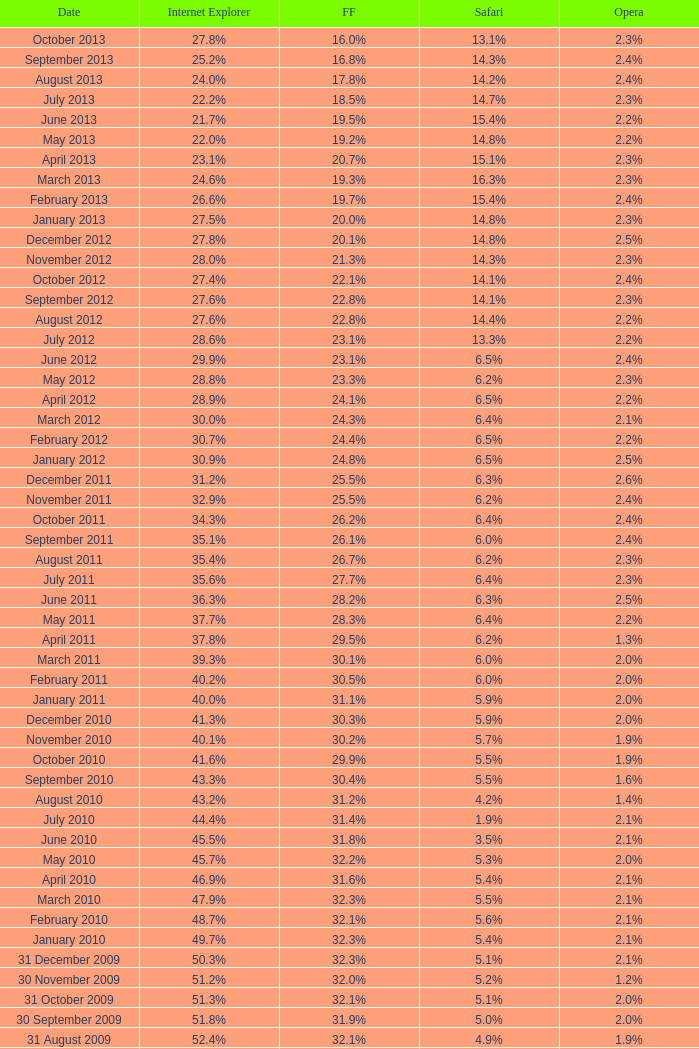What is the safari value with a 2.4% opera and 29.9% internet explorer? 6.5%. Would you be able to parse every entry in this table? {'header': ['Date', 'Internet Explorer', 'FF', 'Safari', 'Opera'], 'rows': [['October 2013', '27.8%', '16.0%', '13.1%', '2.3%'], ['September 2013', '25.2%', '16.8%', '14.3%', '2.4%'], ['August 2013', '24.0%', '17.8%', '14.2%', '2.4%'], ['July 2013', '22.2%', '18.5%', '14.7%', '2.3%'], ['June 2013', '21.7%', '19.5%', '15.4%', '2.2%'], ['May 2013', '22.0%', '19.2%', '14.8%', '2.2%'], ['April 2013', '23.1%', '20.7%', '15.1%', '2.3%'], ['March 2013', '24.6%', '19.3%', '16.3%', '2.3%'], ['February 2013', '26.6%', '19.7%', '15.4%', '2.4%'], ['January 2013', '27.5%', '20.0%', '14.8%', '2.3%'], ['December 2012', '27.8%', '20.1%', '14.8%', '2.5%'], ['November 2012', '28.0%', '21.3%', '14.3%', '2.3%'], ['October 2012', '27.4%', '22.1%', '14.1%', '2.4%'], ['September 2012', '27.6%', '22.8%', '14.1%', '2.3%'], ['August 2012', '27.6%', '22.8%', '14.4%', '2.2%'], ['July 2012', '28.6%', '23.1%', '13.3%', '2.2%'], ['June 2012', '29.9%', '23.1%', '6.5%', '2.4%'], ['May 2012', '28.8%', '23.3%', '6.2%', '2.3%'], ['April 2012', '28.9%', '24.1%', '6.5%', '2.2%'], ['March 2012', '30.0%', '24.3%', '6.4%', '2.1%'], ['February 2012', '30.7%', '24.4%', '6.5%', '2.2%'], ['January 2012', '30.9%', '24.8%', '6.5%', '2.5%'], ['December 2011', '31.2%', '25.5%', '6.3%', '2.6%'], ['November 2011', '32.9%', '25.5%', '6.2%', '2.4%'], ['October 2011', '34.3%', '26.2%', '6.4%', '2.4%'], ['September 2011', '35.1%', '26.1%', '6.0%', '2.4%'], ['August 2011', '35.4%', '26.7%', '6.2%', '2.3%'], ['July 2011', '35.6%', '27.7%', '6.4%', '2.3%'], ['June 2011', '36.3%', '28.2%', '6.3%', '2.5%'], ['May 2011', '37.7%', '28.3%', '6.4%', '2.2%'], ['April 2011', '37.8%', '29.5%', '6.2%', '1.3%'], ['March 2011', '39.3%', '30.1%', '6.0%', '2.0%'], ['February 2011', '40.2%', '30.5%', '6.0%', '2.0%'], ['January 2011', '40.0%', '31.1%', '5.9%', '2.0%'], ['December 2010', '41.3%', '30.3%', '5.9%', '2.0%'], ['November 2010', '40.1%', '30.2%', '5.7%', '1.9%'], ['October 2010', '41.6%', '29.9%', '5.5%', '1.9%'], ['September 2010', '43.3%', '30.4%', '5.5%', '1.6%'], ['August 2010', '43.2%', '31.2%', '4.2%', '1.4%'], ['July 2010', '44.4%', '31.4%', '1.9%', '2.1%'], ['June 2010', '45.5%', '31.8%', '3.5%', '2.1%'], ['May 2010', '45.7%', '32.2%', '5.3%', '2.0%'], ['April 2010', '46.9%', '31.6%', '5.4%', '2.1%'], ['March 2010', '47.9%', '32.3%', '5.5%', '2.1%'], ['February 2010', '48.7%', '32.1%', '5.6%', '2.1%'], ['January 2010', '49.7%', '32.3%', '5.4%', '2.1%'], ['31 December 2009', '50.3%', '32.3%', '5.1%', '2.1%'], ['30 November 2009', '51.2%', '32.0%', '5.2%', '1.2%'], ['31 October 2009', '51.3%', '32.1%', '5.1%', '2.0%'], ['30 September 2009', '51.8%', '31.9%', '5.0%', '2.0%'], ['31 August 2009', '52.4%', '32.1%', '4.9%', '1.9%'], ['31 July 2009', '53.1%', '31.7%', '4.6%', '1.8%'], ['30 June 2009', '57.1%', '31.6%', '3.2%', '2.0%'], ['31 May 2009', '57.5%', '31.4%', '3.1%', '2.0%'], ['30 April 2009', '57.6%', '31.6%', '2.9%', '2.0%'], ['31 March 2009', '57.8%', '31.5%', '2.8%', '2.0%'], ['28 February 2009', '58.1%', '31.3%', '2.7%', '2.0%'], ['31 January 2009', '58.4%', '31.1%', '2.7%', '2.0%'], ['31 December 2008', '58.6%', '31.1%', '2.9%', '2.1%'], ['30 November 2008', '59.0%', '30.8%', '3.0%', '2.0%'], ['31 October 2008', '59.4%', '30.6%', '3.0%', '2.0%'], ['30 September 2008', '57.3%', '32.5%', '2.7%', '2.0%'], ['31 August 2008', '58.7%', '31.4%', '2.4%', '2.1%'], ['31 July 2008', '60.9%', '29.7%', '2.4%', '2.0%'], ['30 June 2008', '61.7%', '29.1%', '2.5%', '2.0%'], ['31 May 2008', '61.9%', '28.9%', '2.7%', '2.0%'], ['30 April 2008', '62.0%', '28.8%', '2.8%', '2.0%'], ['31 March 2008', '62.0%', '28.8%', '2.8%', '2.0%'], ['29 February 2008', '62.0%', '28.7%', '2.8%', '2.0%'], ['31 January 2008', '62.2%', '28.7%', '2.7%', '2.0%'], ['1 December 2007', '62.8%', '28.0%', '2.6%', '2.0%'], ['10 November 2007', '63.0%', '27.8%', '2.5%', '2.0%'], ['30 October 2007', '65.5%', '26.3%', '2.3%', '1.8%'], ['20 September 2007', '66.6%', '25.6%', '2.1%', '1.8%'], ['30 August 2007', '66.7%', '25.5%', '2.1%', '1.8%'], ['30 July 2007', '66.9%', '25.1%', '2.2%', '1.8%'], ['30 June 2007', '66.9%', '25.1%', '2.3%', '1.8%'], ['30 May 2007', '67.1%', '24.8%', '2.4%', '1.8%'], ['Date', 'Internet Explorer', 'Firefox', 'Safari', 'Opera']]} 